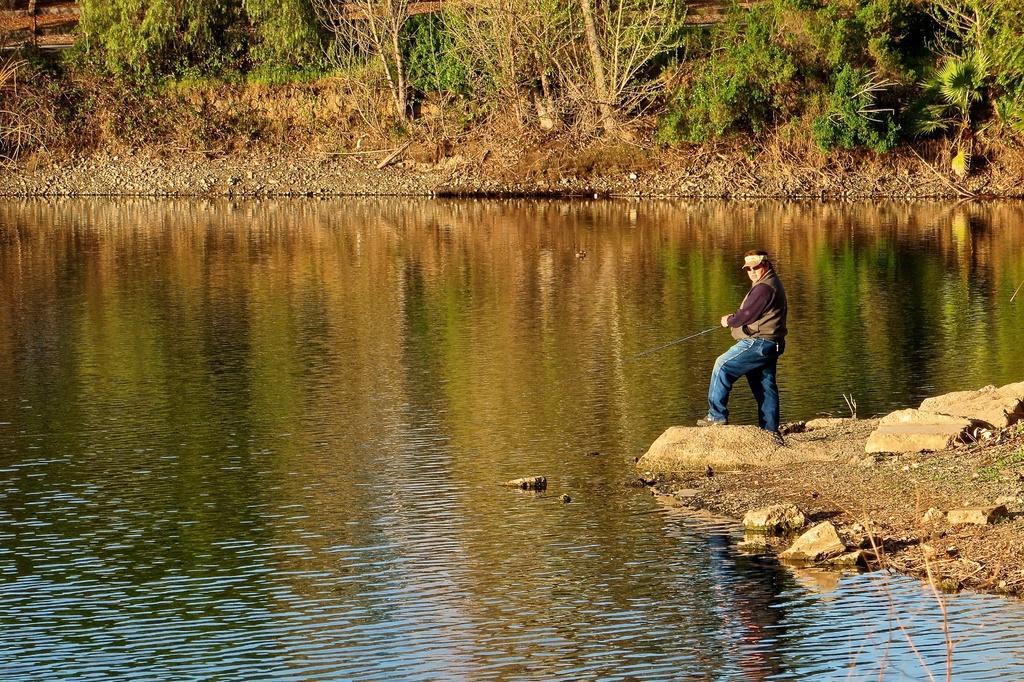Describe this image in one or two sentences. In this image a man is holding a fishing rod. He is fishing. This is the water body. On the ground there are stones. In the background there are trees. 